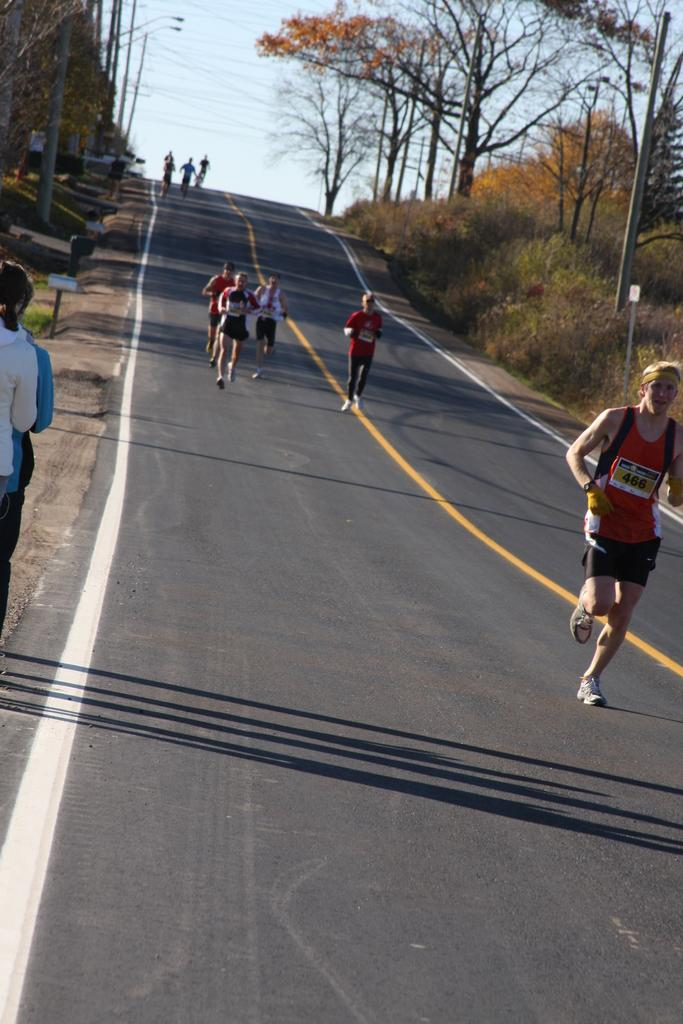What are the people in the image doing? There is a group of people running on the road in the image. What can be seen on the sides of the road? Name boards and electric poles are visible on the sides of the road. What type of vegetation is present in the image? Trees are visible in the image. What else can be seen in the image besides the people and trees? There are some unspecified objects present in the image. What is visible in the background of the image? The sky is visible in the background of the image. What type of statement is being made by the basket in the image? There is no basket present in the image, so it is not possible to answer that question. 